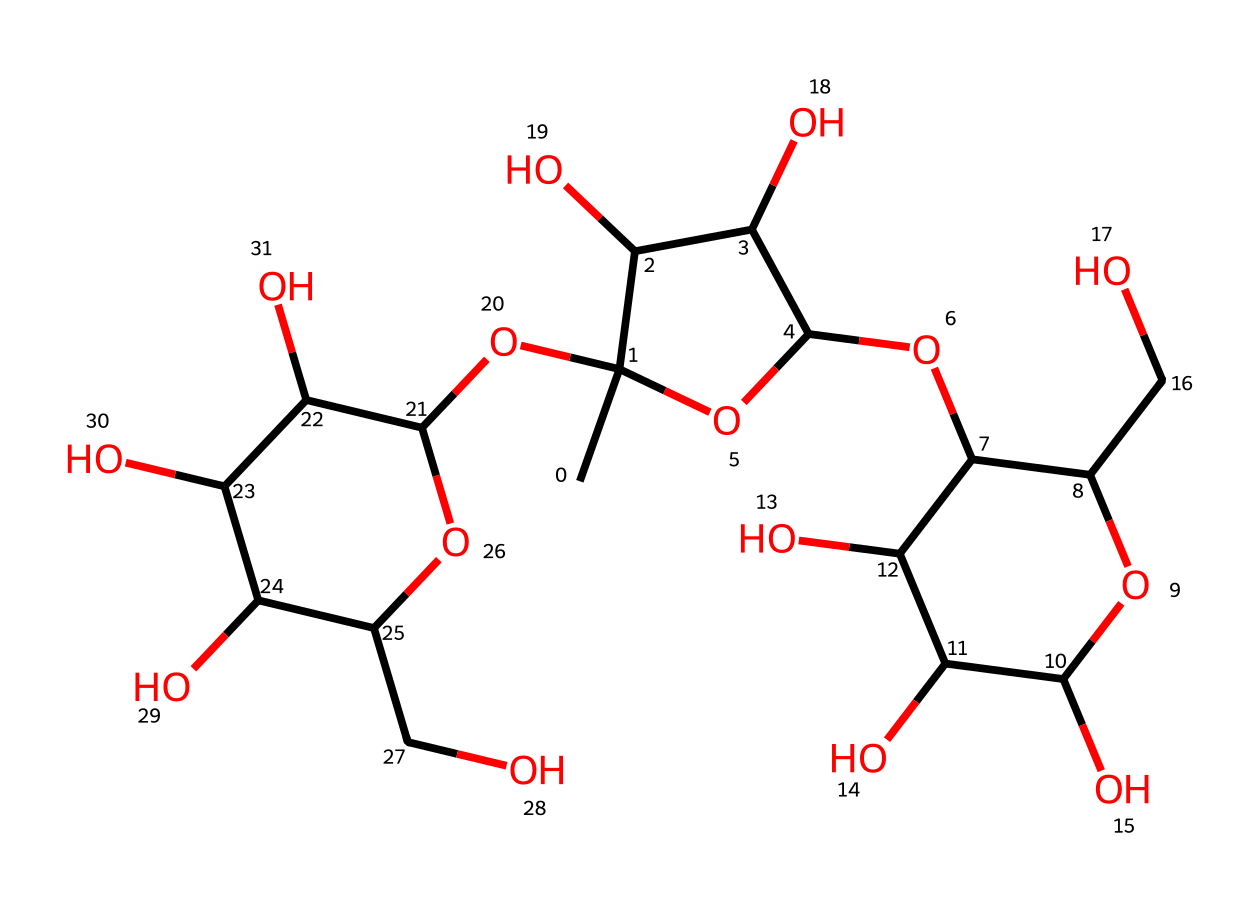What is the primary type of carbohydrate represented in this SMILES? The SMILES provided represents a polysaccharide because it consists of multiple sugar units (monosaccharides) linked together. The branching and multiple hydroxyl groups indicate a more complex structure typical of polysaccharides rather than simple sugars.
Answer: polysaccharide How many carbon atoms are present in this molecule? By analyzing the structure represented in the SMILES, we can count the carbon atoms, indicated as 'C'. In total, there are 18 carbon atoms in this carbohydrate structure.
Answer: 18 How many hydroxyl groups (-OH) does this molecule contain? In the given SMILES, hydroxyl groups are identified by the part of the structure that contains 'O' connected to 'C'. After careful counting of the -OH groups within the structure, it is determined that there are 9 hydroxyl groups in this molecule.
Answer: 9 What type of linkage connects the sugar units in this polysaccharide? The linkages between the sugar units in this type of polysaccharide are typically glycosidic bonds, which can be recognized in the structure where the -OH groups interact. Specifically, the presence of oxygen atoms connecting different ring structures shows glycosidic bonds in action.
Answer: glycosidic What is the main function of agar in marine biology labs? Agar primarily serves as a gelling agent that creates a solid medium allowing for the growth of microorganisms, including marine species in lab environments. Its polysaccharide structure provides the necessary texture for solidifying culture media.
Answer: gelling agent 